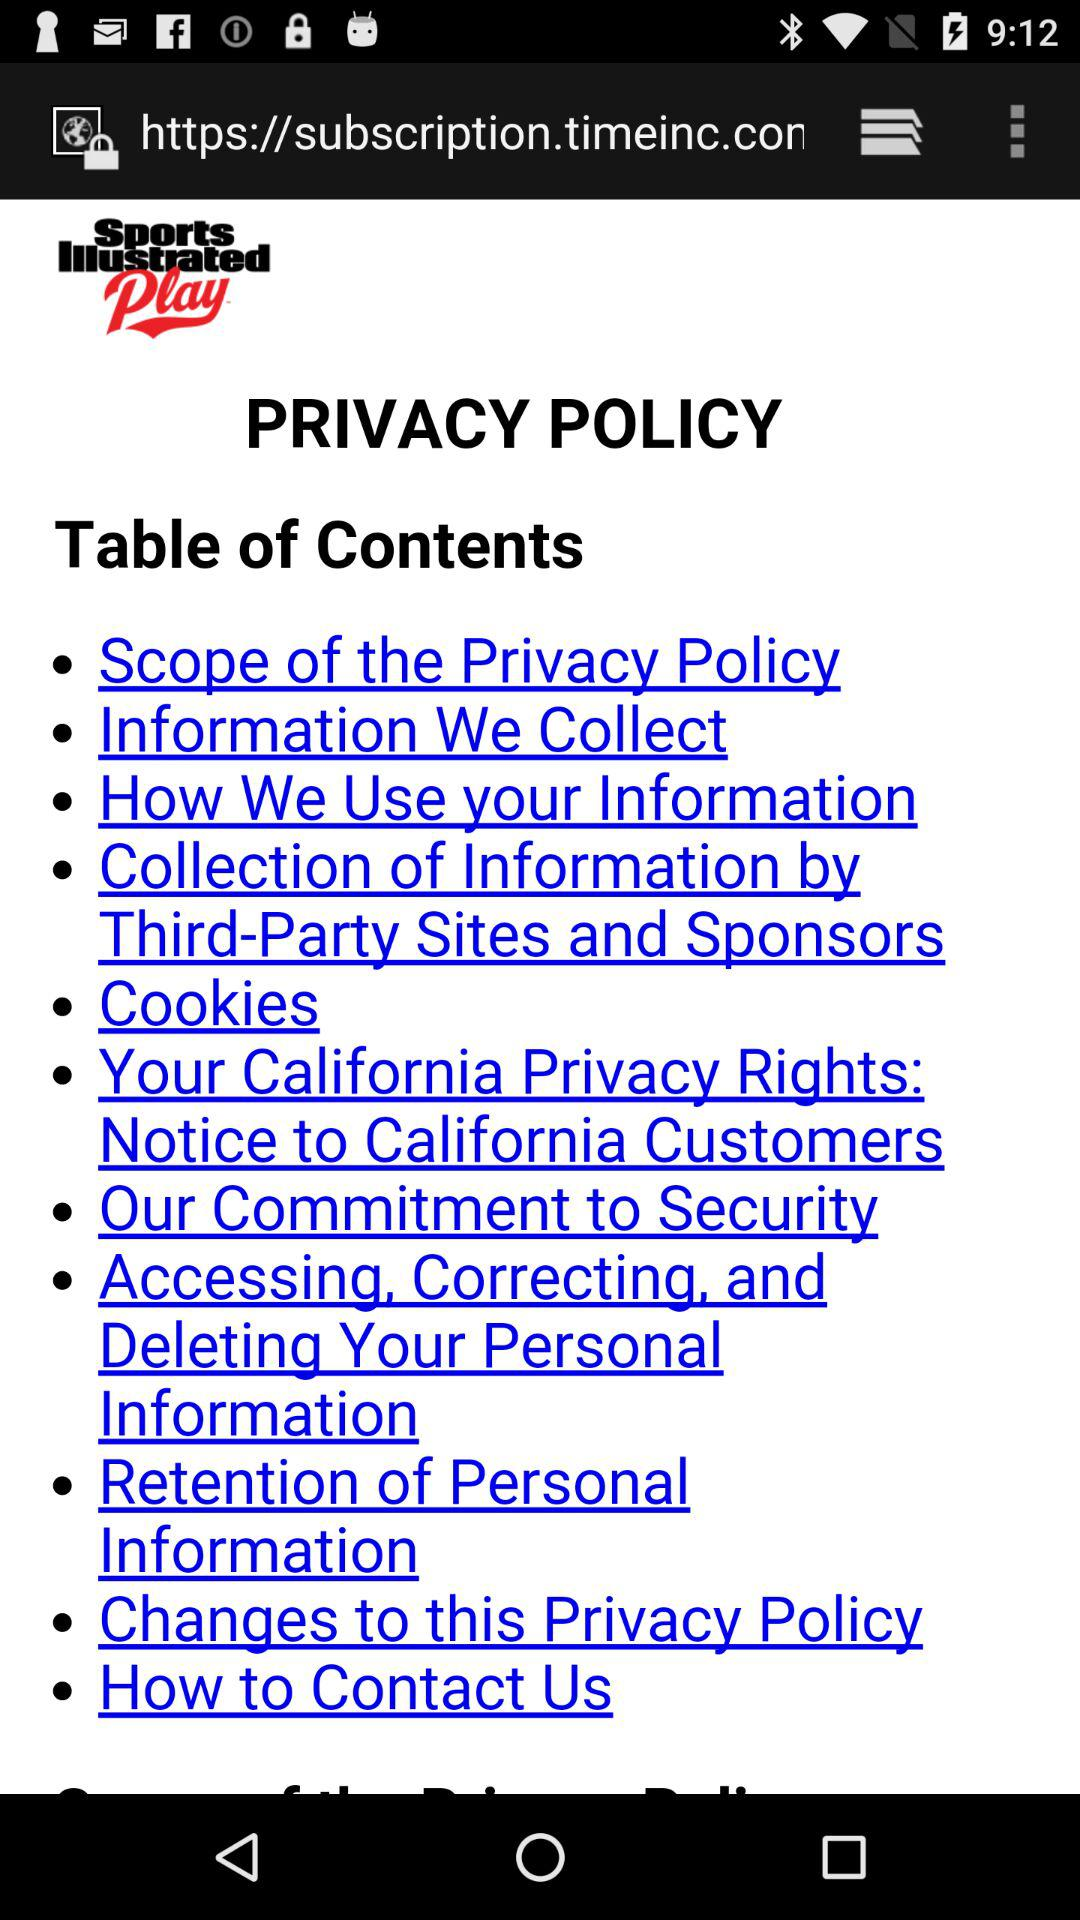What is the application name? The application name is "Sports Illustrated Play". 